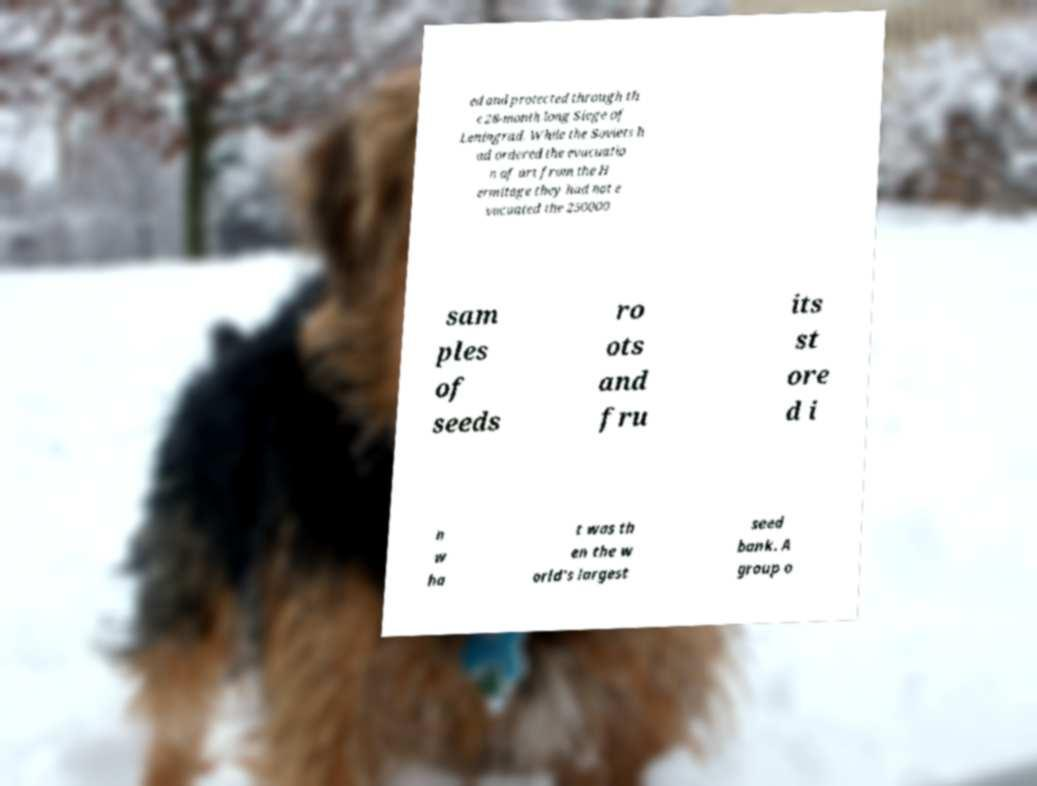Could you extract and type out the text from this image? ed and protected through th e 28-month long Siege of Leningrad. While the Soviets h ad ordered the evacuatio n of art from the H ermitage they had not e vacuated the 250000 sam ples of seeds ro ots and fru its st ore d i n w ha t was th en the w orld's largest seed bank. A group o 